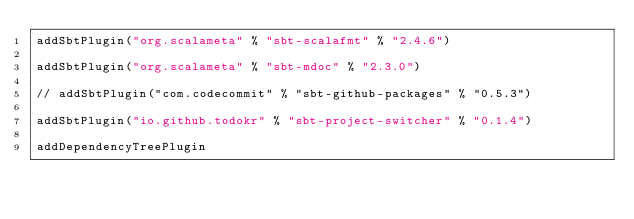<code> <loc_0><loc_0><loc_500><loc_500><_Scala_>addSbtPlugin("org.scalameta" % "sbt-scalafmt" % "2.4.6")

addSbtPlugin("org.scalameta" % "sbt-mdoc" % "2.3.0")

// addSbtPlugin("com.codecommit" % "sbt-github-packages" % "0.5.3")

addSbtPlugin("io.github.todokr" % "sbt-project-switcher" % "0.1.4")

addDependencyTreePlugin
</code> 